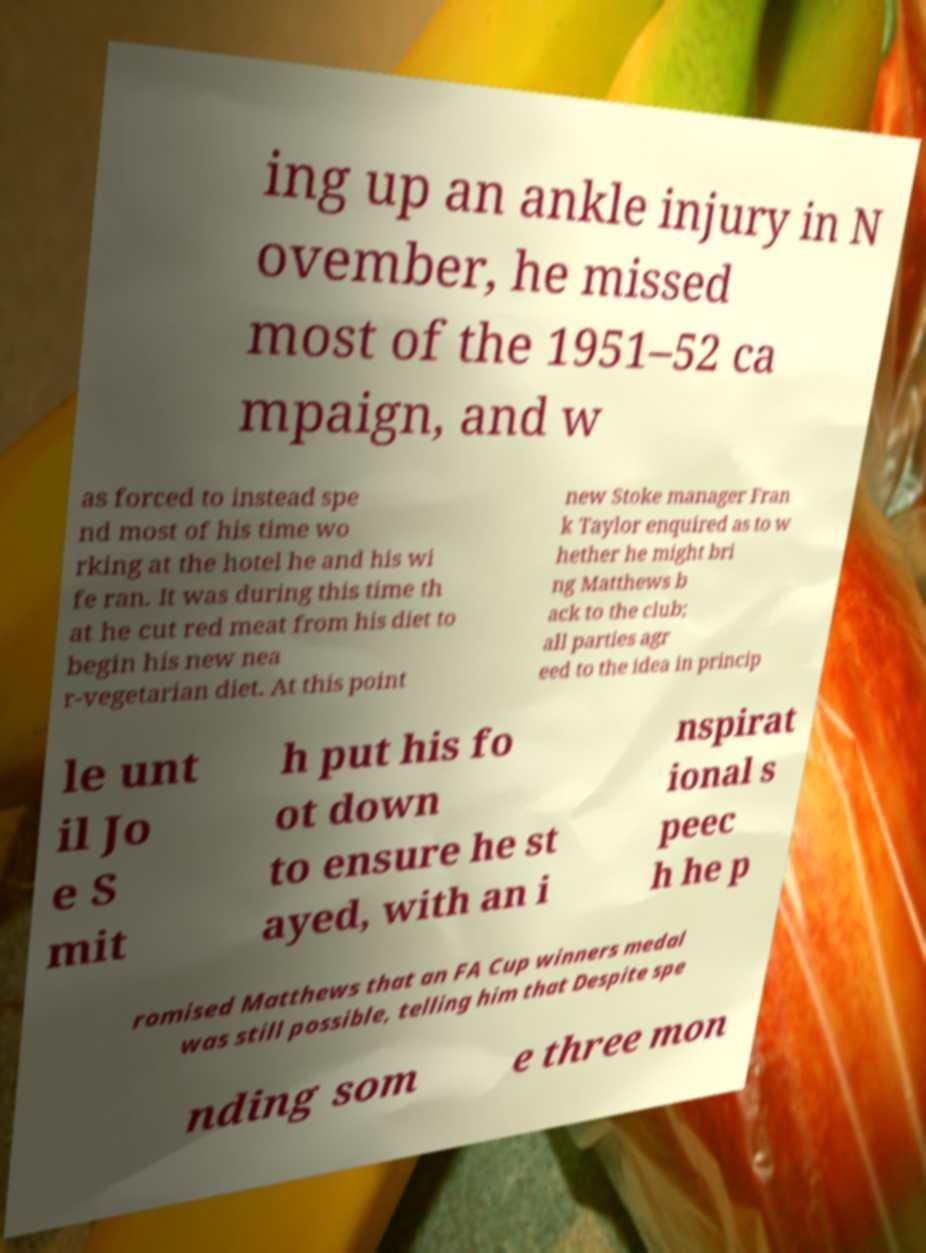Please read and relay the text visible in this image. What does it say? ing up an ankle injury in N ovember, he missed most of the 1951–52 ca mpaign, and w as forced to instead spe nd most of his time wo rking at the hotel he and his wi fe ran. It was during this time th at he cut red meat from his diet to begin his new nea r-vegetarian diet. At this point new Stoke manager Fran k Taylor enquired as to w hether he might bri ng Matthews b ack to the club; all parties agr eed to the idea in princip le unt il Jo e S mit h put his fo ot down to ensure he st ayed, with an i nspirat ional s peec h he p romised Matthews that an FA Cup winners medal was still possible, telling him that Despite spe nding som e three mon 